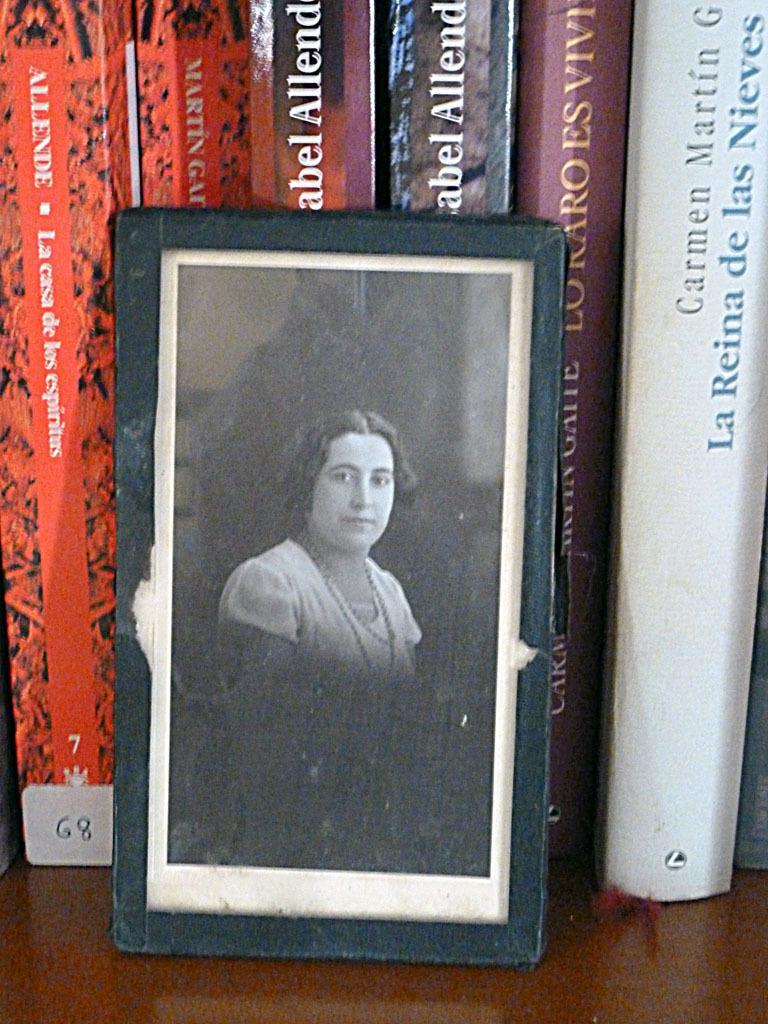How would you summarize this image in a sentence or two? This image is taken indoors. At the bottom of the match that is table. In the background there are a few books on the table. In the middle of the image there is a picture frame of a woman on the table. 